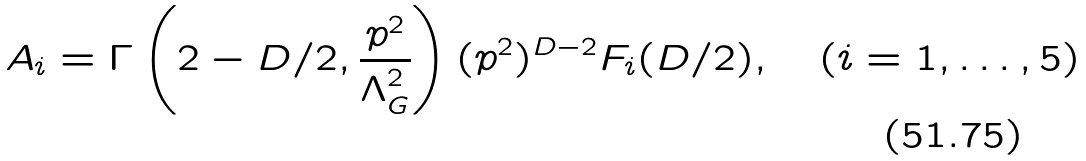<formula> <loc_0><loc_0><loc_500><loc_500>A _ { i } = \Gamma \left ( 2 - D / 2 , \frac { p ^ { 2 } } { \Lambda _ { G } ^ { 2 } } \right ) ( p ^ { 2 } ) ^ { D - 2 } F _ { i } ( D / 2 ) , \quad ( i = 1 , \dots , 5 )</formula> 